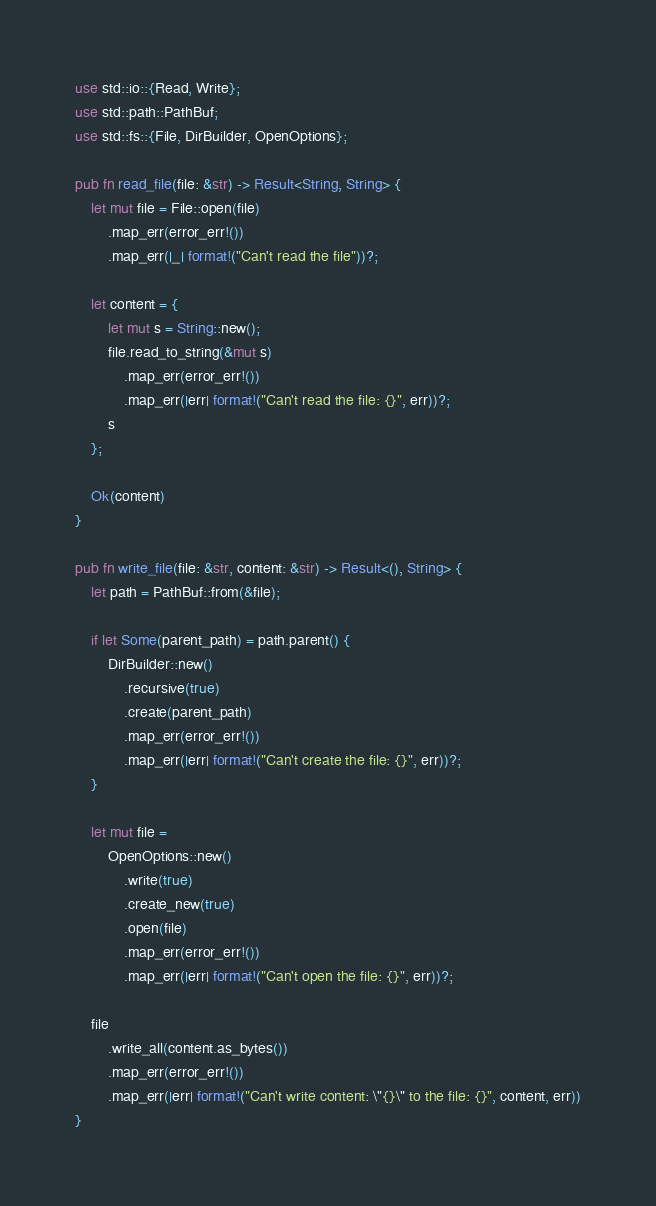<code> <loc_0><loc_0><loc_500><loc_500><_Rust_>use std::io::{Read, Write};
use std::path::PathBuf;
use std::fs::{File, DirBuilder, OpenOptions};

pub fn read_file(file: &str) -> Result<String, String> {
    let mut file = File::open(file)
        .map_err(error_err!())
        .map_err(|_| format!("Can't read the file"))?;

    let content = {
        let mut s = String::new();
        file.read_to_string(&mut s)
            .map_err(error_err!())
            .map_err(|err| format!("Can't read the file: {}", err))?;
        s
    };

    Ok(content)
}

pub fn write_file(file: &str, content: &str) -> Result<(), String> {
    let path = PathBuf::from(&file);

    if let Some(parent_path) = path.parent() {
        DirBuilder::new()
            .recursive(true)
            .create(parent_path)
            .map_err(error_err!())
            .map_err(|err| format!("Can't create the file: {}", err))?;
    }

    let mut file =
        OpenOptions::new()
            .write(true)
            .create_new(true)
            .open(file)
            .map_err(error_err!())
            .map_err(|err| format!("Can't open the file: {}", err))?;

    file
        .write_all(content.as_bytes())
        .map_err(error_err!())
        .map_err(|err| format!("Can't write content: \"{}\" to the file: {}", content, err))
}</code> 